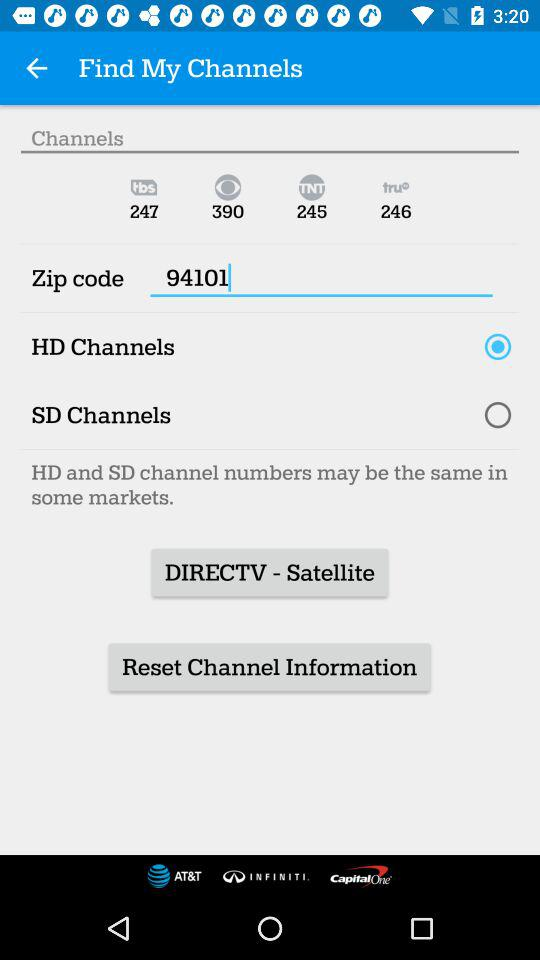What kind of channel is selected? The selected channel is "HD Channels". 